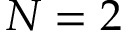Convert formula to latex. <formula><loc_0><loc_0><loc_500><loc_500>N = 2</formula> 